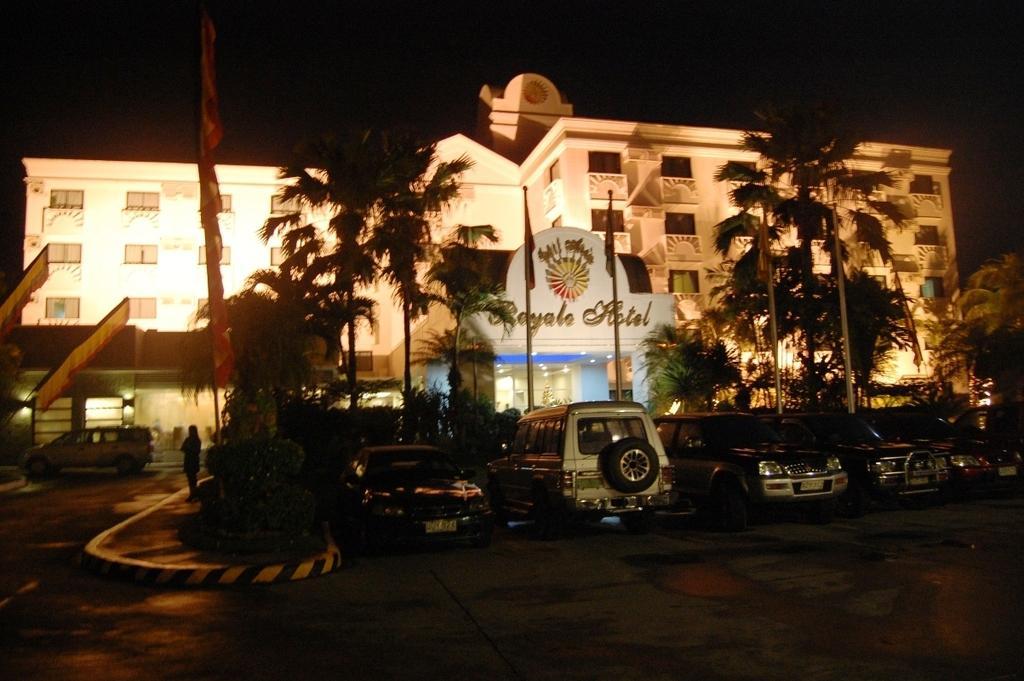Could you give a brief overview of what you see in this image? In this picture I can see there are few cars parked at right side and there is a person standing at the left side, there is a building in the backdrop, with a name board and lights, there are plants and trees and the sky is dark. 